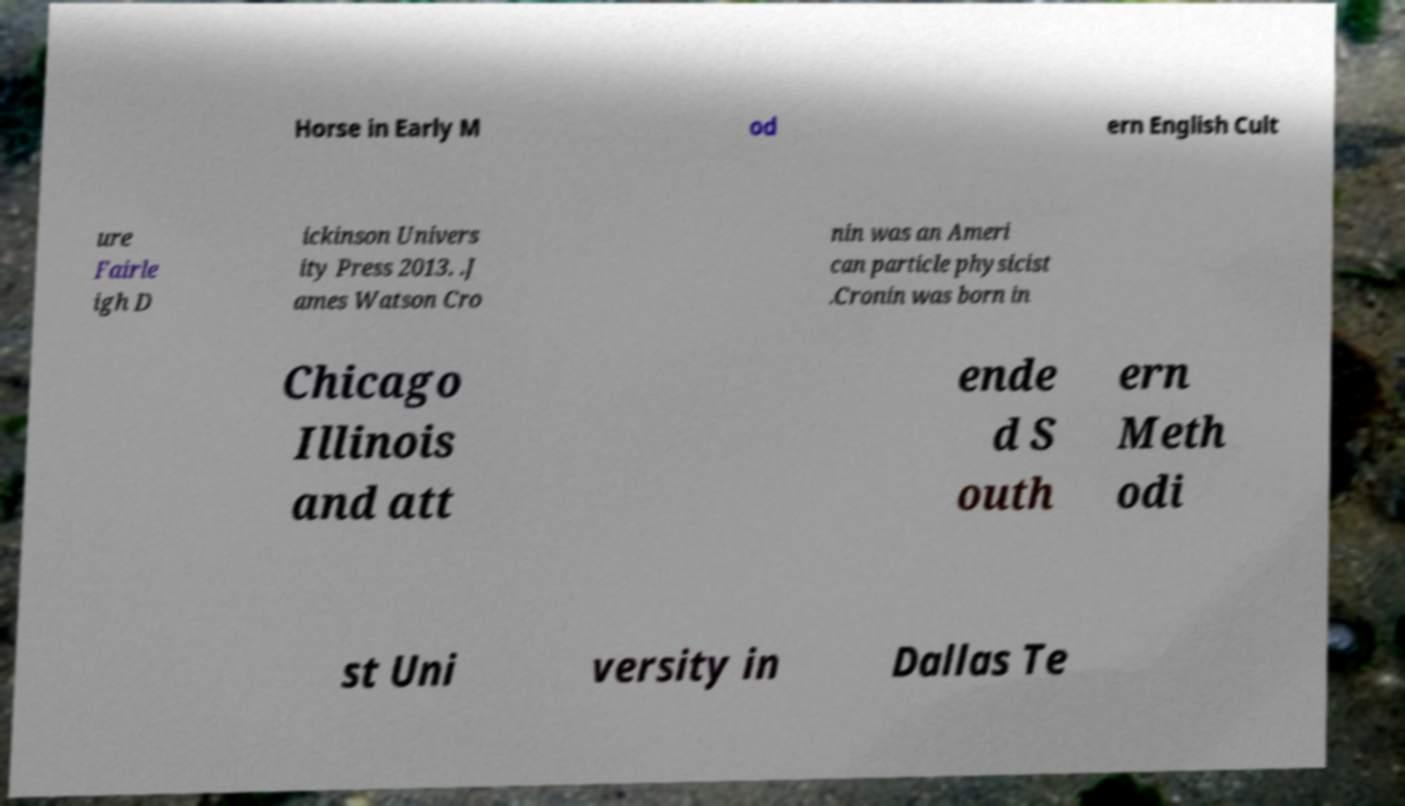Could you assist in decoding the text presented in this image and type it out clearly? Horse in Early M od ern English Cult ure Fairle igh D ickinson Univers ity Press 2013. .J ames Watson Cro nin was an Ameri can particle physicist .Cronin was born in Chicago Illinois and att ende d S outh ern Meth odi st Uni versity in Dallas Te 